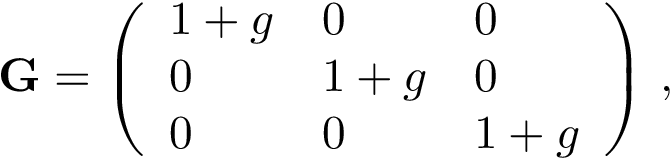<formula> <loc_0><loc_0><loc_500><loc_500>G = \left ( \begin{array} { l l l } { 1 + g } & { 0 } & { 0 } \\ { 0 } & { 1 + g } & { 0 } \\ { 0 } & { 0 } & { 1 + g } \end{array} \right ) \, ,</formula> 